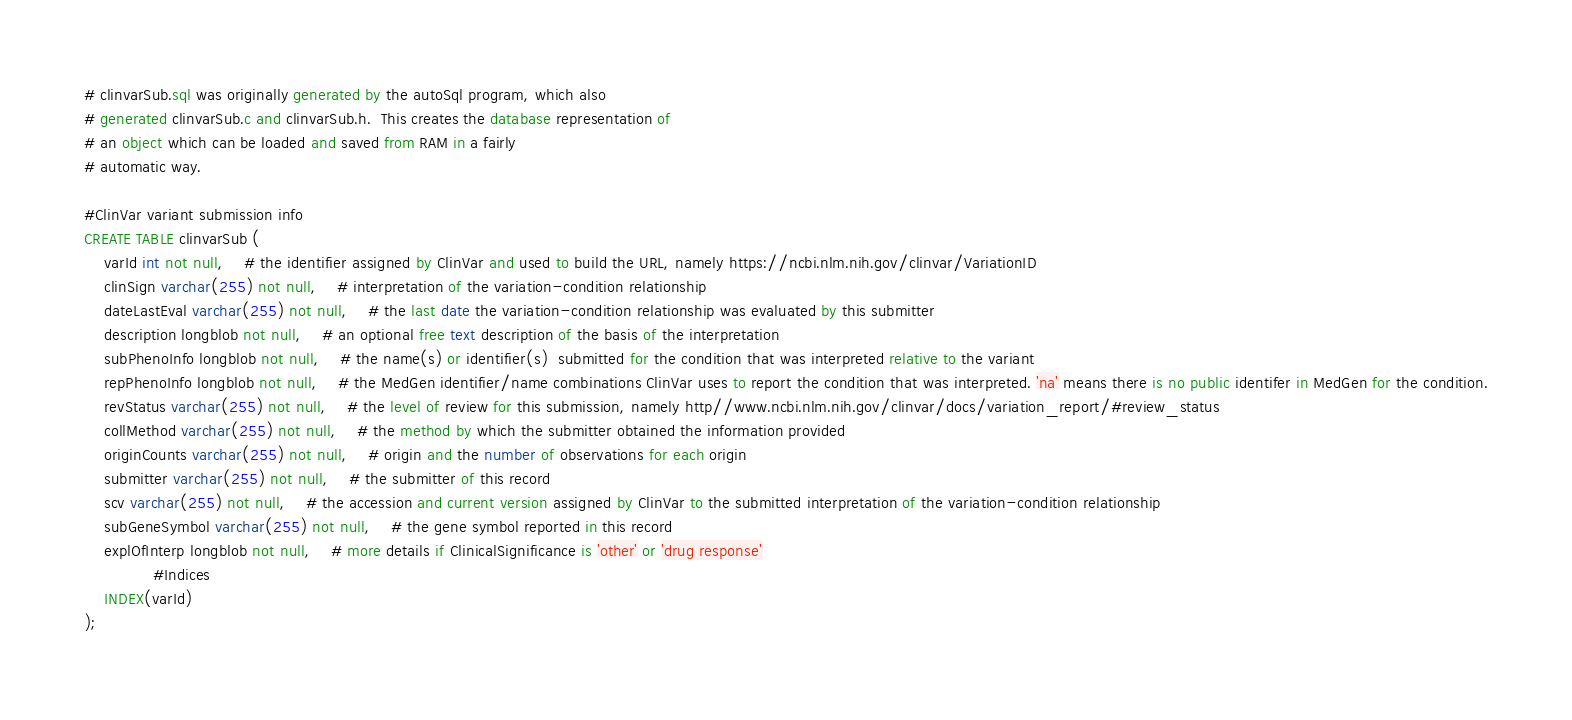Convert code to text. <code><loc_0><loc_0><loc_500><loc_500><_SQL_># clinvarSub.sql was originally generated by the autoSql program, which also 
# generated clinvarSub.c and clinvarSub.h.  This creates the database representation of
# an object which can be loaded and saved from RAM in a fairly 
# automatic way.

#ClinVar variant submission info
CREATE TABLE clinvarSub (
    varId int not null,	# the identifier assigned by ClinVar and used to build the URL, namely https://ncbi.nlm.nih.gov/clinvar/VariationID
    clinSign varchar(255) not null,	# interpretation of the variation-condition relationship
    dateLastEval varchar(255) not null,	# the last date the variation-condition relationship was evaluated by this submitter
    description longblob not null,	# an optional free text description of the basis of the interpretation
    subPhenoInfo longblob not null,	# the name(s) or identifier(s)  submitted for the condition that was interpreted relative to the variant
    repPhenoInfo longblob not null,	# the MedGen identifier/name combinations ClinVar uses to report the condition that was interpreted. 'na' means there is no public identifer in MedGen for the condition.
    revStatus varchar(255) not null,	# the level of review for this submission, namely http//www.ncbi.nlm.nih.gov/clinvar/docs/variation_report/#review_status
    collMethod varchar(255) not null,	# the method by which the submitter obtained the information provided
    originCounts varchar(255) not null,	# origin and the number of observations for each origin
    submitter varchar(255) not null,	# the submitter of this record
    scv varchar(255) not null,	# the accession and current version assigned by ClinVar to the submitted interpretation of the variation-condition relationship
    subGeneSymbol varchar(255) not null,	# the gene symbol reported in this record
    explOfInterp longblob not null,	# more details if ClinicalSignificance is 'other' or 'drug response'
              #Indices
    INDEX(varId)
);
</code> 